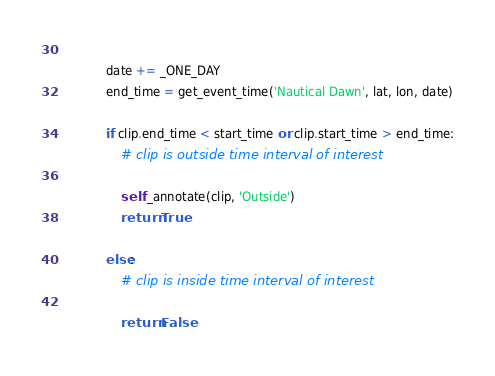Convert code to text. <code><loc_0><loc_0><loc_500><loc_500><_Python_>            
            date += _ONE_DAY
            end_time = get_event_time('Nautical Dawn', lat, lon, date)
    
            if clip.end_time < start_time or clip.start_time > end_time:
                # clip is outside time interval of interest
                
                self._annotate(clip, 'Outside')
                return True
            
            else:
                # clip is inside time interval of interest
                
                return False
</code> 